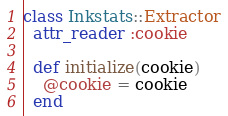Convert code to text. <code><loc_0><loc_0><loc_500><loc_500><_Ruby_>class Inkstats::Extractor
  attr_reader :cookie

  def initialize(cookie)
    @cookie = cookie
  end
</code> 